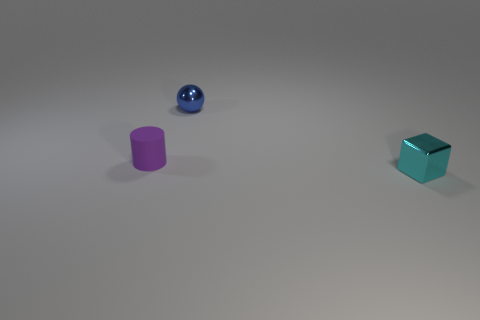There is a metal object that is in front of the tiny purple rubber thing; what is its shape? The metal object in front of the tiny purple rubber item is shaped like a cube. Its reflective surface suggests that it's made of a material like polished steel or aluminum, which contrasts with the matte texture of the purple object. 